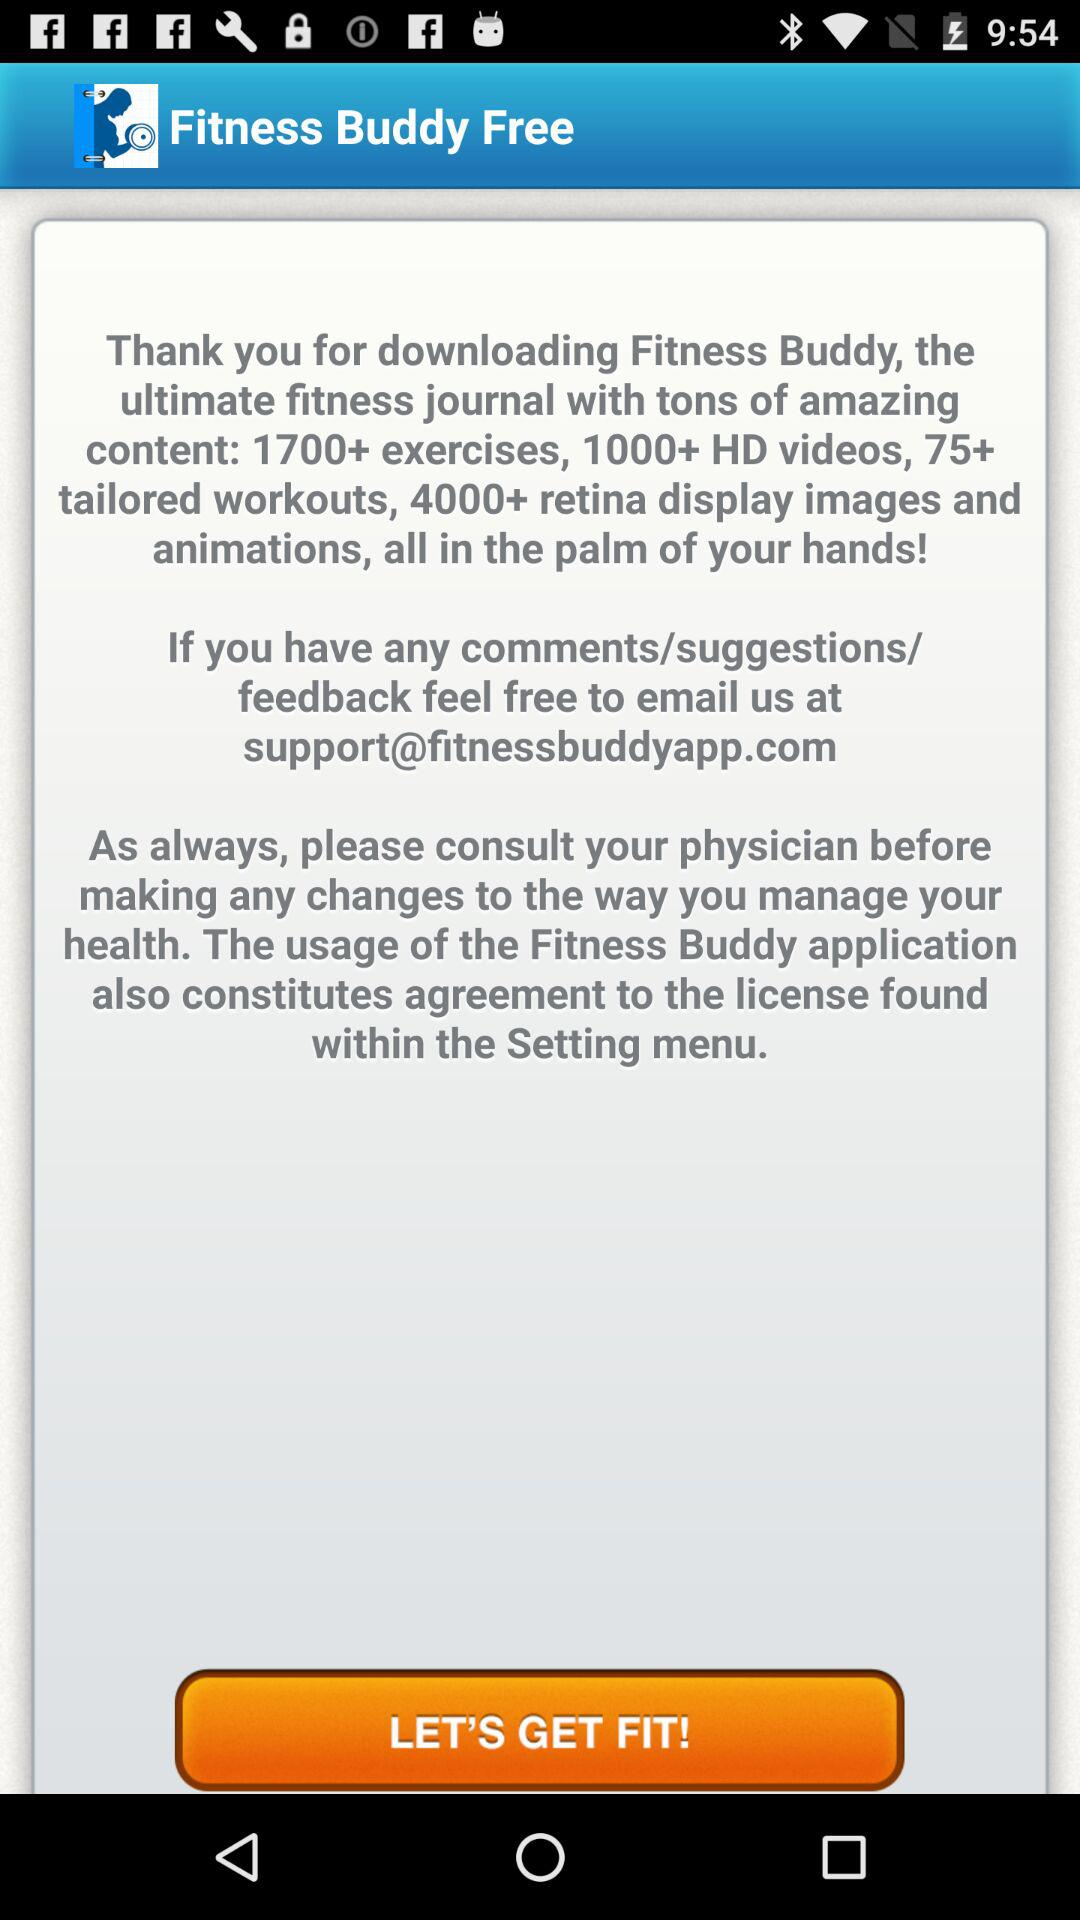What is the available content in the "Fitness Buddy" app? The available contents are 1700+ exercises, 1000+ HD videos, 75+ tailored workouts, 4000+ retina display images and animations. 